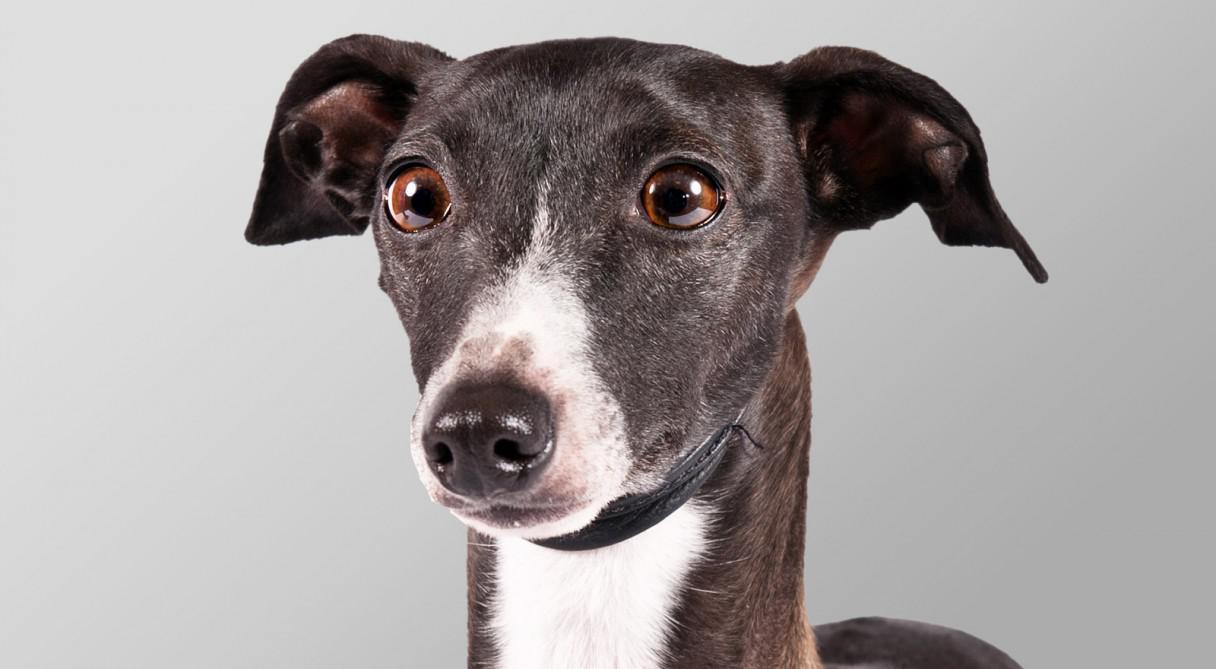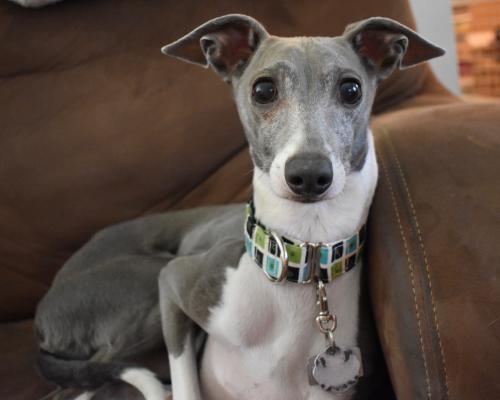The first image is the image on the left, the second image is the image on the right. Assess this claim about the two images: "No less than four dog legs are visible". Correct or not? Answer yes or no. No. The first image is the image on the left, the second image is the image on the right. Assess this claim about the two images: "The right image shows a hound with its body touched by something beige that is soft and ribbed.". Correct or not? Answer yes or no. No. The first image is the image on the left, the second image is the image on the right. Given the left and right images, does the statement "Left image shows a dog with a bright white neck marking." hold true? Answer yes or no. Yes. The first image is the image on the left, the second image is the image on the right. Considering the images on both sides, is "A Miniature Grehound dog is shown laying down in at least one of the images." valid? Answer yes or no. Yes. 